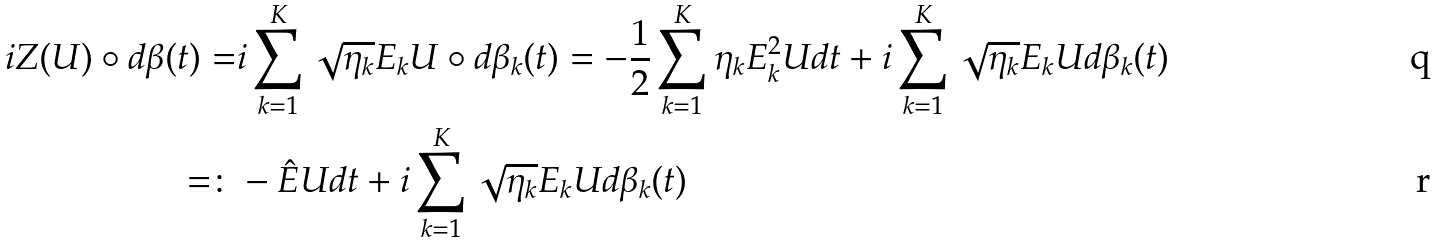Convert formula to latex. <formula><loc_0><loc_0><loc_500><loc_500>i Z ( U ) \circ d \beta ( t ) = & i \sum _ { k = 1 } ^ { K } \sqrt { \eta _ { k } } E _ { k } U \circ d \beta _ { k } ( t ) = - \frac { 1 } { 2 } \sum _ { k = 1 } ^ { K } \eta _ { k } E _ { k } ^ { 2 } U d t + i \sum _ { k = 1 } ^ { K } \sqrt { \eta _ { k } } E _ { k } U d \beta _ { k } ( t ) \\ = \colon & - \hat { E } U d t + i \sum _ { k = 1 } ^ { K } \sqrt { \eta _ { k } } E _ { k } U d \beta _ { k } ( t )</formula> 